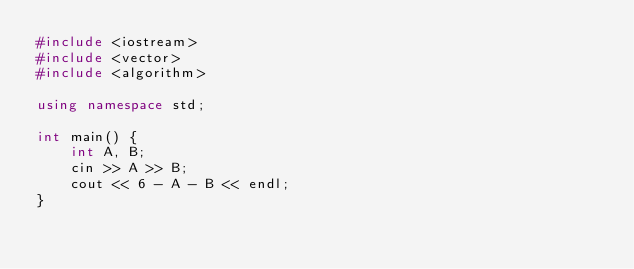Convert code to text. <code><loc_0><loc_0><loc_500><loc_500><_C++_>#include <iostream>
#include <vector>
#include <algorithm>

using namespace std;

int main() {
    int A, B;
    cin >> A >> B;
    cout << 6 - A - B << endl;
}</code> 